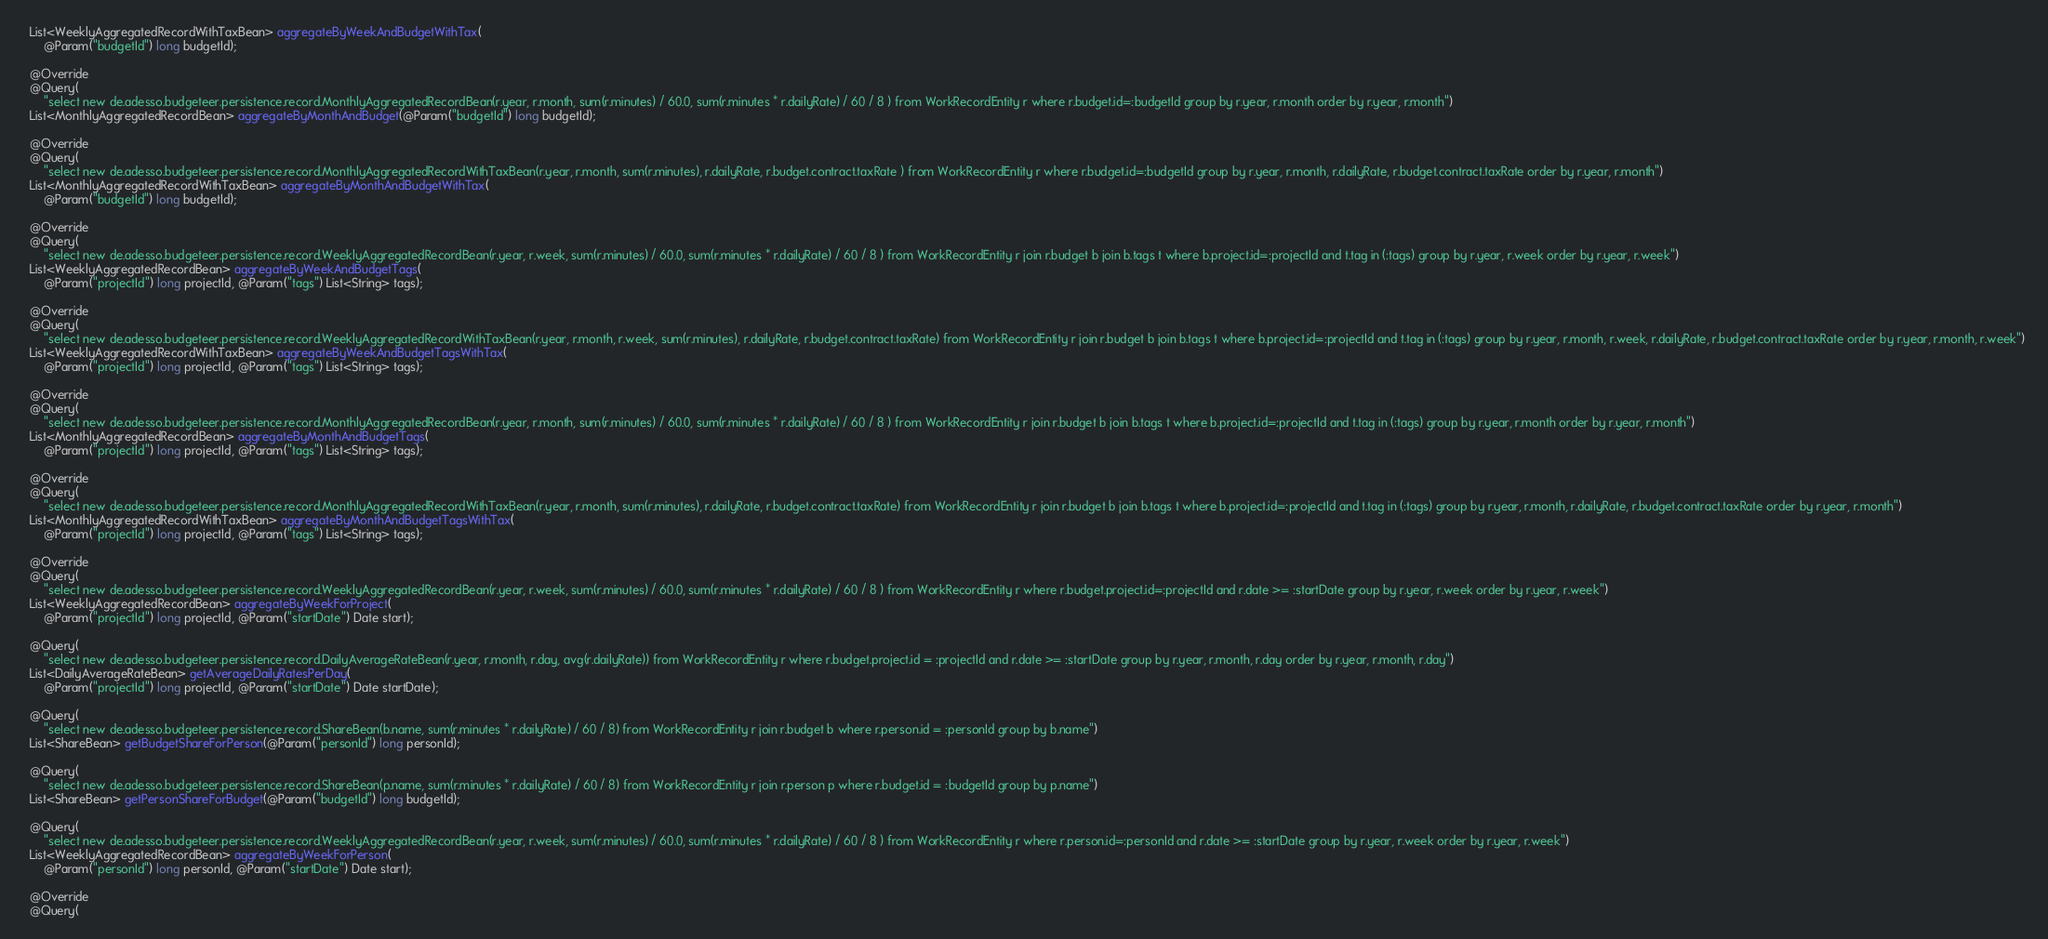Convert code to text. <code><loc_0><loc_0><loc_500><loc_500><_Java_>  List<WeeklyAggregatedRecordWithTaxBean> aggregateByWeekAndBudgetWithTax(
      @Param("budgetId") long budgetId);

  @Override
  @Query(
      "select new de.adesso.budgeteer.persistence.record.MonthlyAggregatedRecordBean(r.year, r.month, sum(r.minutes) / 60.0, sum(r.minutes * r.dailyRate) / 60 / 8 ) from WorkRecordEntity r where r.budget.id=:budgetId group by r.year, r.month order by r.year, r.month")
  List<MonthlyAggregatedRecordBean> aggregateByMonthAndBudget(@Param("budgetId") long budgetId);

  @Override
  @Query(
      "select new de.adesso.budgeteer.persistence.record.MonthlyAggregatedRecordWithTaxBean(r.year, r.month, sum(r.minutes), r.dailyRate, r.budget.contract.taxRate ) from WorkRecordEntity r where r.budget.id=:budgetId group by r.year, r.month, r.dailyRate, r.budget.contract.taxRate order by r.year, r.month")
  List<MonthlyAggregatedRecordWithTaxBean> aggregateByMonthAndBudgetWithTax(
      @Param("budgetId") long budgetId);

  @Override
  @Query(
      "select new de.adesso.budgeteer.persistence.record.WeeklyAggregatedRecordBean(r.year, r.week, sum(r.minutes) / 60.0, sum(r.minutes * r.dailyRate) / 60 / 8 ) from WorkRecordEntity r join r.budget b join b.tags t where b.project.id=:projectId and t.tag in (:tags) group by r.year, r.week order by r.year, r.week")
  List<WeeklyAggregatedRecordBean> aggregateByWeekAndBudgetTags(
      @Param("projectId") long projectId, @Param("tags") List<String> tags);

  @Override
  @Query(
      "select new de.adesso.budgeteer.persistence.record.WeeklyAggregatedRecordWithTaxBean(r.year, r.month, r.week, sum(r.minutes), r.dailyRate, r.budget.contract.taxRate) from WorkRecordEntity r join r.budget b join b.tags t where b.project.id=:projectId and t.tag in (:tags) group by r.year, r.month, r.week, r.dailyRate, r.budget.contract.taxRate order by r.year, r.month, r.week")
  List<WeeklyAggregatedRecordWithTaxBean> aggregateByWeekAndBudgetTagsWithTax(
      @Param("projectId") long projectId, @Param("tags") List<String> tags);

  @Override
  @Query(
      "select new de.adesso.budgeteer.persistence.record.MonthlyAggregatedRecordBean(r.year, r.month, sum(r.minutes) / 60.0, sum(r.minutes * r.dailyRate) / 60 / 8 ) from WorkRecordEntity r join r.budget b join b.tags t where b.project.id=:projectId and t.tag in (:tags) group by r.year, r.month order by r.year, r.month")
  List<MonthlyAggregatedRecordBean> aggregateByMonthAndBudgetTags(
      @Param("projectId") long projectId, @Param("tags") List<String> tags);

  @Override
  @Query(
      "select new de.adesso.budgeteer.persistence.record.MonthlyAggregatedRecordWithTaxBean(r.year, r.month, sum(r.minutes), r.dailyRate, r.budget.contract.taxRate) from WorkRecordEntity r join r.budget b join b.tags t where b.project.id=:projectId and t.tag in (:tags) group by r.year, r.month, r.dailyRate, r.budget.contract.taxRate order by r.year, r.month")
  List<MonthlyAggregatedRecordWithTaxBean> aggregateByMonthAndBudgetTagsWithTax(
      @Param("projectId") long projectId, @Param("tags") List<String> tags);

  @Override
  @Query(
      "select new de.adesso.budgeteer.persistence.record.WeeklyAggregatedRecordBean(r.year, r.week, sum(r.minutes) / 60.0, sum(r.minutes * r.dailyRate) / 60 / 8 ) from WorkRecordEntity r where r.budget.project.id=:projectId and r.date >= :startDate group by r.year, r.week order by r.year, r.week")
  List<WeeklyAggregatedRecordBean> aggregateByWeekForProject(
      @Param("projectId") long projectId, @Param("startDate") Date start);

  @Query(
      "select new de.adesso.budgeteer.persistence.record.DailyAverageRateBean(r.year, r.month, r.day, avg(r.dailyRate)) from WorkRecordEntity r where r.budget.project.id = :projectId and r.date >= :startDate group by r.year, r.month, r.day order by r.year, r.month, r.day")
  List<DailyAverageRateBean> getAverageDailyRatesPerDay(
      @Param("projectId") long projectId, @Param("startDate") Date startDate);

  @Query(
      "select new de.adesso.budgeteer.persistence.record.ShareBean(b.name, sum(r.minutes * r.dailyRate) / 60 / 8) from WorkRecordEntity r join r.budget b where r.person.id = :personId group by b.name")
  List<ShareBean> getBudgetShareForPerson(@Param("personId") long personId);

  @Query(
      "select new de.adesso.budgeteer.persistence.record.ShareBean(p.name, sum(r.minutes * r.dailyRate) / 60 / 8) from WorkRecordEntity r join r.person p where r.budget.id = :budgetId group by p.name")
  List<ShareBean> getPersonShareForBudget(@Param("budgetId") long budgetId);

  @Query(
      "select new de.adesso.budgeteer.persistence.record.WeeklyAggregatedRecordBean(r.year, r.week, sum(r.minutes) / 60.0, sum(r.minutes * r.dailyRate) / 60 / 8 ) from WorkRecordEntity r where r.person.id=:personId and r.date >= :startDate group by r.year, r.week order by r.year, r.week")
  List<WeeklyAggregatedRecordBean> aggregateByWeekForPerson(
      @Param("personId") long personId, @Param("startDate") Date start);

  @Override
  @Query(</code> 